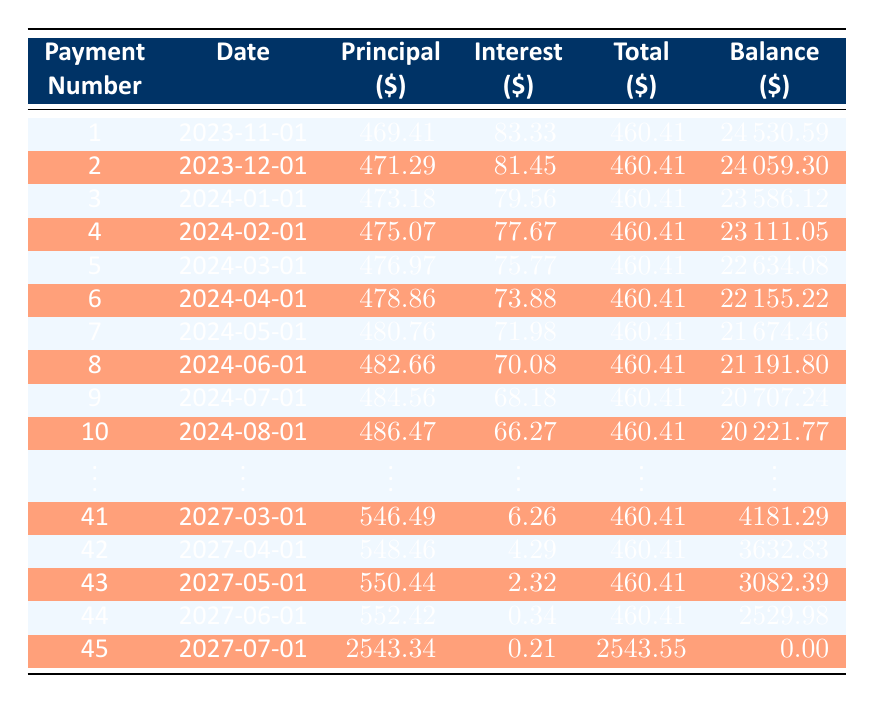What is the monthly payment for the car loan? The monthly payment amount is specified as 460.41 in the loan details.
Answer: 460.41 How much principal is paid in the first payment? The principal payment for the first payment, listed in the table, is 469.41.
Answer: 469.41 What is the remaining balance after the third payment? To find the remaining balance after the third payment, refer to the table where the remaining balance for the third payment is stated as 23586.12.
Answer: 23586.12 How much total has been paid in principal after the first five payments? To find the total principal paid after five payments, sum the principal payments: 469.41 + 471.29 + 473.18 + 475.07 + 476.97 = 2365.92.
Answer: 2365.92 Is the interest payment for the last payment greater than 0? The last payment's interest payment is stated as 0.21, which is greater than 0.
Answer: Yes What is the average principal payment made in the first ten payments? To find the average, sum the principal payments for the first ten payments and divide by 10: (469.41 + 471.29 + 473.18 + 475.07 + 476.97 + 478.86 + 480.76 + 482.66 + 484.56 + 486.47) = 4810.2; dividing by 10 gives an average of 481.02.
Answer: 481.02 How many payments are needed to completely pay off the loan? The table indicates there are 45 payments in total, with the final balance reaching 0. This means it takes 45 payments to fully pay off the loan.
Answer: 45 What is the difference in interest payment between the first and last payment? The interest payment for the first payment is 83.33, and for the last payment, it is 0.21. The difference is calculated as 83.33 - 0.21 = 83.12.
Answer: 83.12 In which month does the loan balance drop below 10,000? Looking through the table, the loan balance drops below 10,000 after the 30th payment when it is recorded as 10090.71. The payment date for the 30th payment is 2026-04-01. Therefore, the loan balance drops below 10,000 in May 2026 (30th payment).
Answer: May 2026 